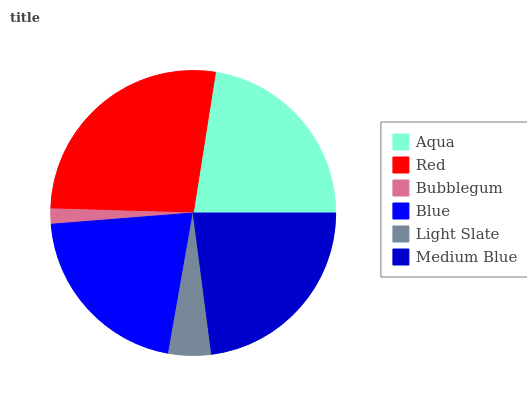Is Bubblegum the minimum?
Answer yes or no. Yes. Is Red the maximum?
Answer yes or no. Yes. Is Red the minimum?
Answer yes or no. No. Is Bubblegum the maximum?
Answer yes or no. No. Is Red greater than Bubblegum?
Answer yes or no. Yes. Is Bubblegum less than Red?
Answer yes or no. Yes. Is Bubblegum greater than Red?
Answer yes or no. No. Is Red less than Bubblegum?
Answer yes or no. No. Is Aqua the high median?
Answer yes or no. Yes. Is Blue the low median?
Answer yes or no. Yes. Is Medium Blue the high median?
Answer yes or no. No. Is Medium Blue the low median?
Answer yes or no. No. 